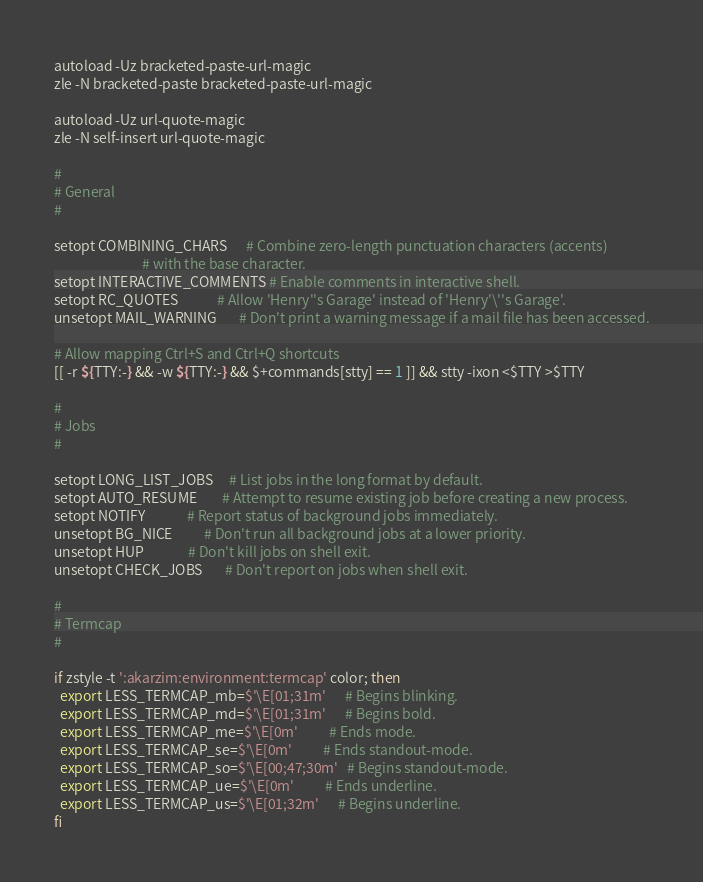Convert code to text. <code><loc_0><loc_0><loc_500><loc_500><_Bash_>autoload -Uz bracketed-paste-url-magic
zle -N bracketed-paste bracketed-paste-url-magic

autoload -Uz url-quote-magic
zle -N self-insert url-quote-magic

#
# General
#

setopt COMBINING_CHARS      # Combine zero-length punctuation characters (accents)
                            # with the base character.
setopt INTERACTIVE_COMMENTS # Enable comments in interactive shell.
setopt RC_QUOTES            # Allow 'Henry''s Garage' instead of 'Henry'\''s Garage'.
unsetopt MAIL_WARNING       # Don't print a warning message if a mail file has been accessed.

# Allow mapping Ctrl+S and Ctrl+Q shortcuts
[[ -r ${TTY:-} && -w ${TTY:-} && $+commands[stty] == 1 ]] && stty -ixon <$TTY >$TTY

#
# Jobs
#

setopt LONG_LIST_JOBS     # List jobs in the long format by default.
setopt AUTO_RESUME        # Attempt to resume existing job before creating a new process.
setopt NOTIFY             # Report status of background jobs immediately.
unsetopt BG_NICE          # Don't run all background jobs at a lower priority.
unsetopt HUP              # Don't kill jobs on shell exit.
unsetopt CHECK_JOBS       # Don't report on jobs when shell exit.

#
# Termcap
#

if zstyle -t ':akarzim:environment:termcap' color; then
  export LESS_TERMCAP_mb=$'\E[01;31m'      # Begins blinking.
  export LESS_TERMCAP_md=$'\E[01;31m'      # Begins bold.
  export LESS_TERMCAP_me=$'\E[0m'          # Ends mode.
  export LESS_TERMCAP_se=$'\E[0m'          # Ends standout-mode.
  export LESS_TERMCAP_so=$'\E[00;47;30m'   # Begins standout-mode.
  export LESS_TERMCAP_ue=$'\E[0m'          # Ends underline.
  export LESS_TERMCAP_us=$'\E[01;32m'      # Begins underline.
fi
</code> 